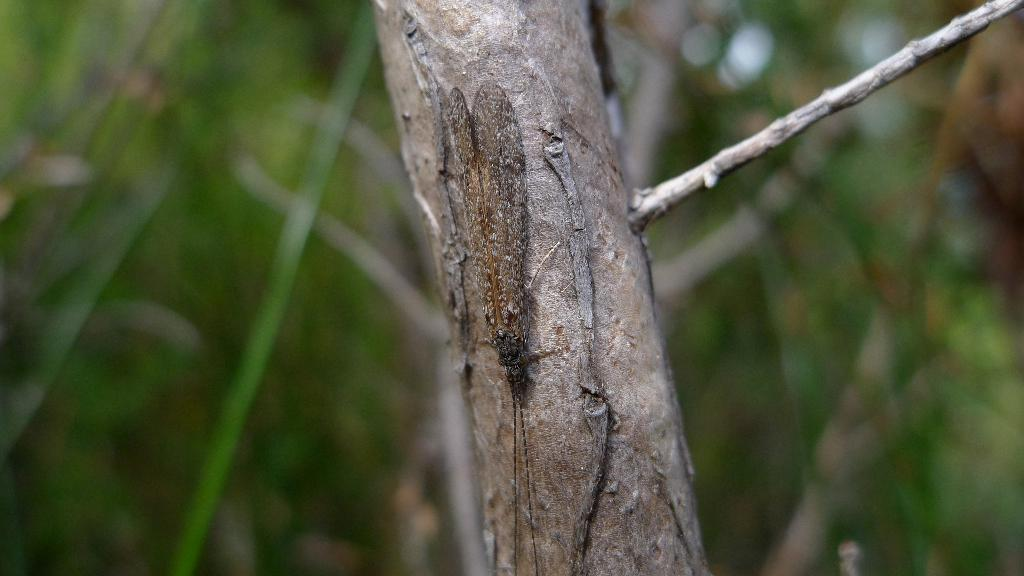What is on the trunk of the tree in the image? There is an insect on the trunk of the tree. What feature does the insect have? The insect has wings. What can be seen on the right side of the image? There is a twig on the right side of the image. How would you describe the background of the image? The backdrop is blurred. What type of gate can be seen in the image? There is no gate present in the image. How does the insect's behavior change when it encounters the bit in the image? There is no bit present in the image, and therefore no interaction between the insect and a bit can be observed. 